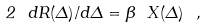Convert formula to latex. <formula><loc_0><loc_0><loc_500><loc_500>2 \ { d R ( \Delta ) } / { d \Delta } = \beta \ X ( \Delta ) \ ,</formula> 